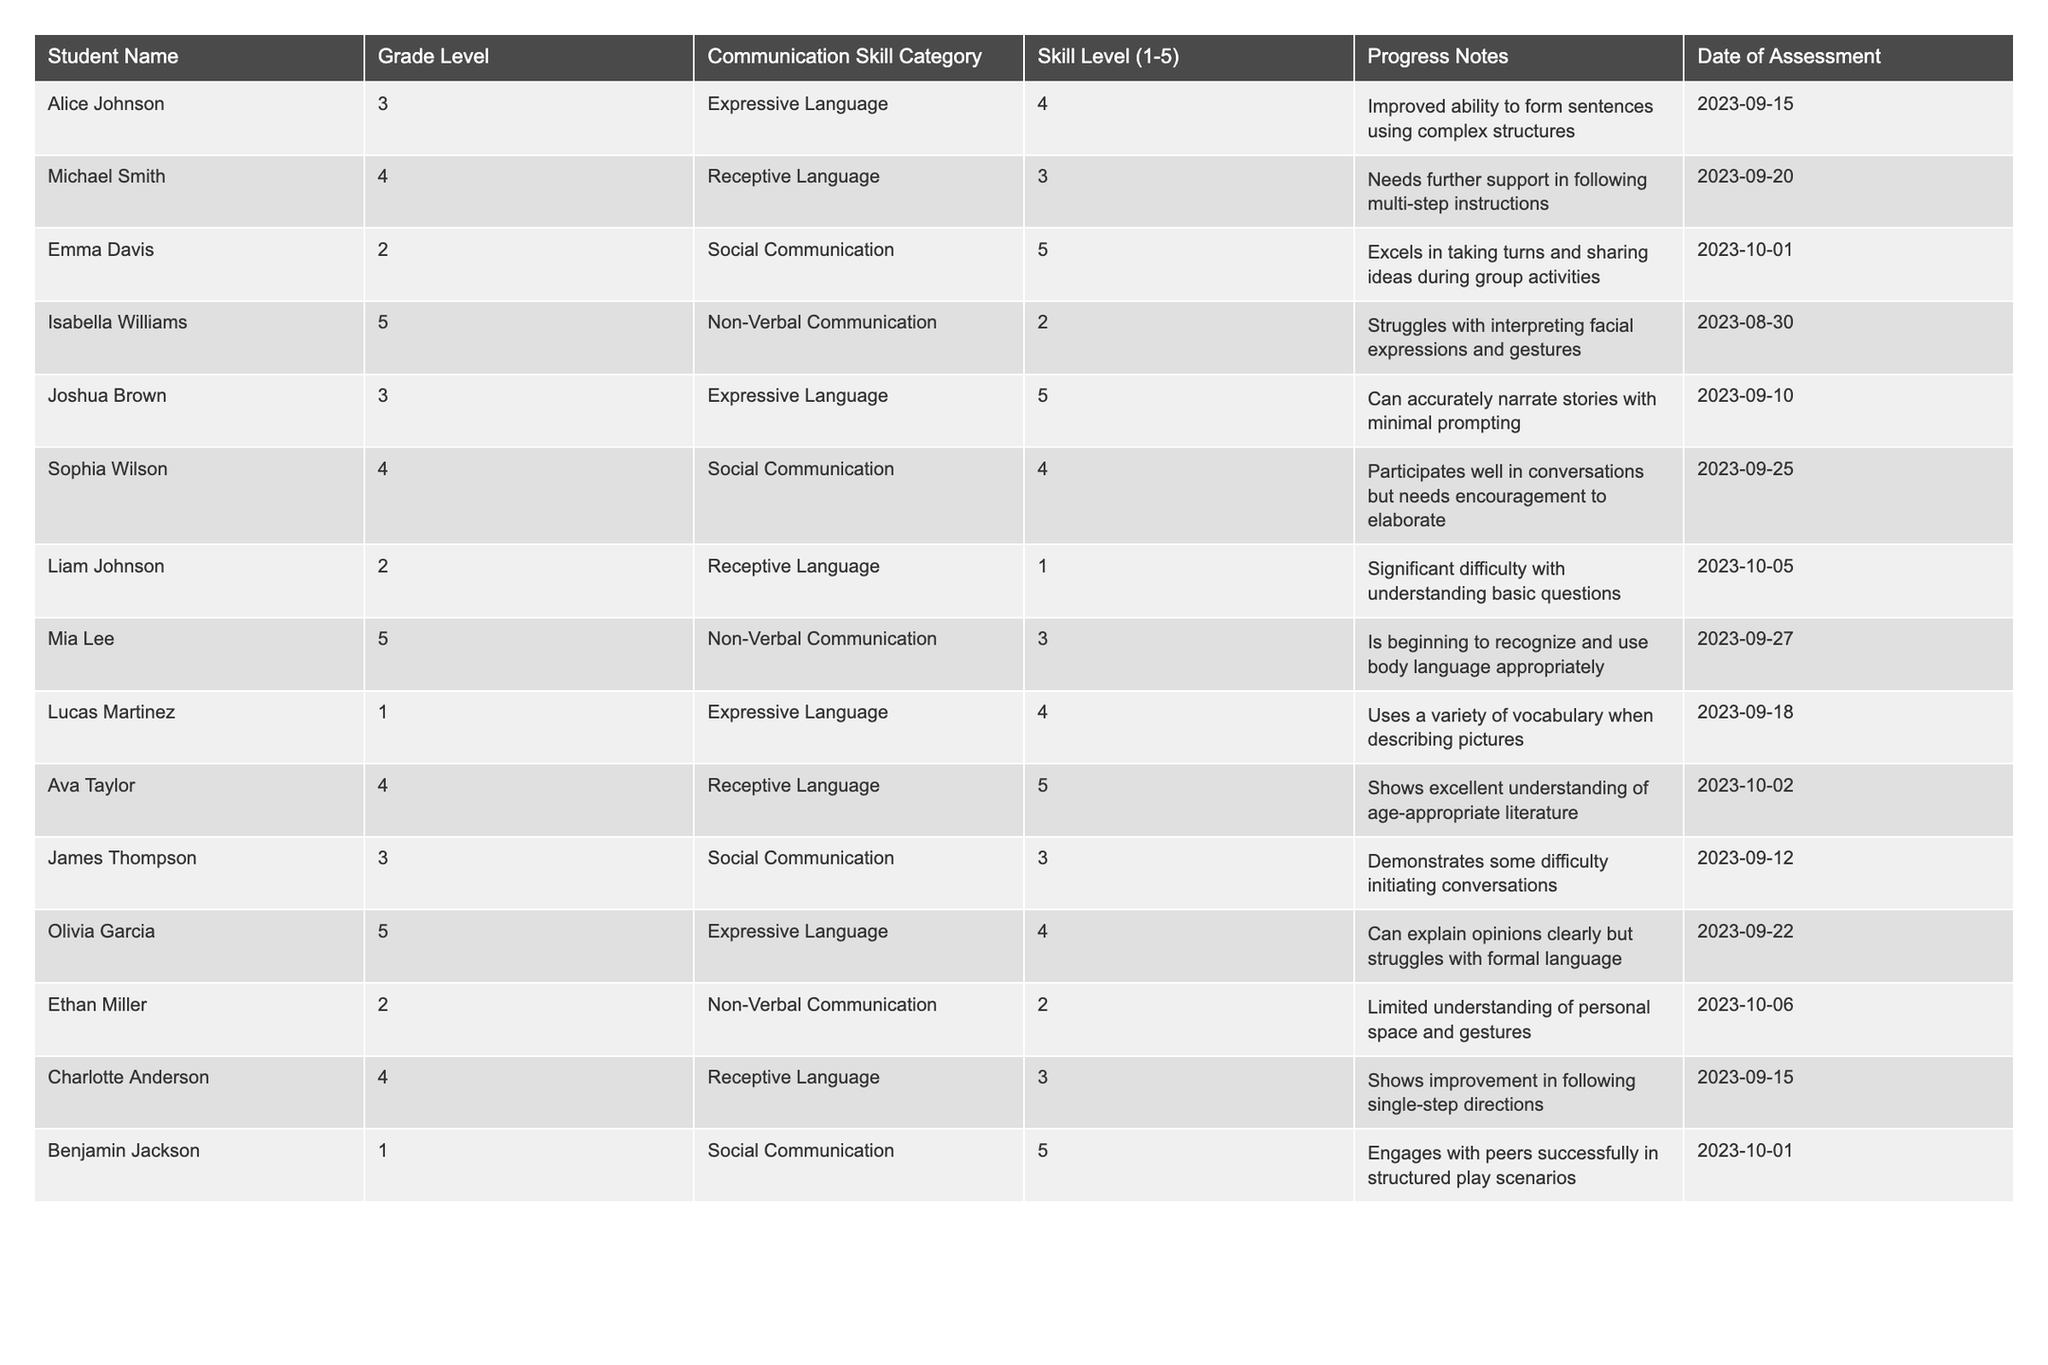What is the skill level of Emma Davis in Social Communication? Refer to the row corresponding to Emma Davis in the table, which shows her skill level is 5.
Answer: 5 How many students are assessed at skill level 1 in Receptive Language? Review the table for students in the Receptive Language category, and identify Liam Johnson, who has a skill level of 1. There is only one student.
Answer: 1 Which student has the highest score in Expressive Language? Look for the maximum value in the Expressive Language category. Joshua Brown and Lucas Martinez both show a skill level of 5, so they are tied for the highest score.
Answer: Joshua Brown and Lucas Martinez What is the average skill level in Non-Verbal Communication among the students? Identify the skill levels in the Non-Verbal Communication category (2, 3, and 2). Sum these values (2 + 3 + 2 = 7), then divide by the number of students in that category (3). The average is 7/3, which is approximately 2.33.
Answer: 2.33 Is Olivia Garcia's skill level in Expressive Language higher than 3? Refer to Olivia Garcia's row in the table, where her skill level in Expressive Language is 4, which is indeed higher than 3.
Answer: Yes How many students are there in grade level 4? Scan through the table to find the number of rows with students in grade level 4. There are 4 students listed in the 4th grade.
Answer: 4 Which student needs further support in following multi-step instructions? Check the row for Michael Smith, who is noted in the table as needing further support in Receptive Language.
Answer: Michael Smith What is the total number of students performing at skill level 5 across all categories? Look through the table and count the rows where the skill level is 5. The students with skill level 5 are Emma Davis, Ava Taylor, and Benjamin Jackson, totaling 3 students.
Answer: 3 Which category does Isabella Williams struggle with the most? From Isabella Williams's row, the table indicates that she struggles in Non-Verbal Communication, where her skill level is 2.
Answer: Non-Verbal Communication Is the skill level of students in Social Communication generally higher, lower, or the same when compared to Expressive Language? Review the skill levels for Social Communication (5, 4, 3, 5) and for Expressive Language (4, 5, 4). Calculating the averages reveals Social Communication has an average of 4.25 while Expressive Language has 4.33, indicating they are fairly similar, but Expressive Language is slightly higher.
Answer: Similar with Expressive Language slightly higher 